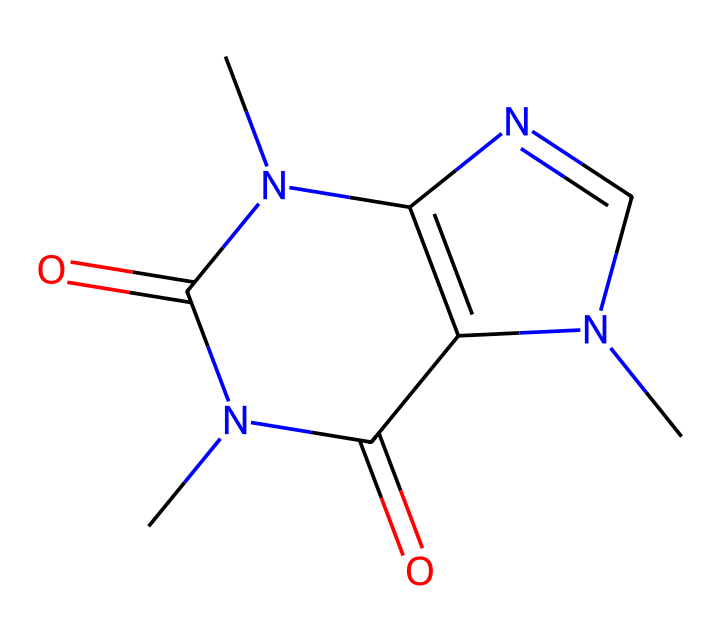What is the molecular formula of caffeine based on the SMILES provided? To derive the molecular formula, we count the atoms represented in the SMILES string. It contains 8 carbon atoms, 10 hydrogen atoms, 4 nitrogen atoms, and 2 oxygen atoms. Thus, the molecular formula can be written as C8H10N4O2.
Answer: C8H10N4O2 How many nitrogen atoms are present in this structure? We examine the SMILES string for occurrences of 'N'. There are 4 occurrences of 'N', indicating the presence of 4 nitrogen atoms in the chemical structure.
Answer: 4 Is this chemical a stimulant? Caffeine is known for its stimulating effects and is commonly consumed for this purpose, thus categorizing it as a stimulant.
Answer: yes What type of chemical structure is represented: cyclic, acyclic, or both? The SMILES shows multiple rings in the structure, confirming that it is a cyclic compound due to the presence of interconnected ring systems (indicated by the numbers after atoms).
Answer: cyclic How many rings are present in the caffeine structure? By analyzing the numbering in the SMILES representation, we note two numbers (1 and 2) indicating the formation of two interconnected rings. Hence, there are 2 rings in the structure.
Answer: 2 What type of bond predominates in caffeine: single or double bonds? By examining the structural annotations in the SMILES, we can see both types of bonds. However, due to the presence of "C=O" segments, there are significant double bonds present alongside single bonds but more than one type.
Answer: both What is the role of the nitrogen atoms in caffeine regarding its activity? The nitrogen atoms contribute to the molecule's basic properties and receptor binding in the body, influencing its interaction with neurotransmitter receptors, which play a crucial role in caffeine's stimulant effects.
Answer: receptor binding 